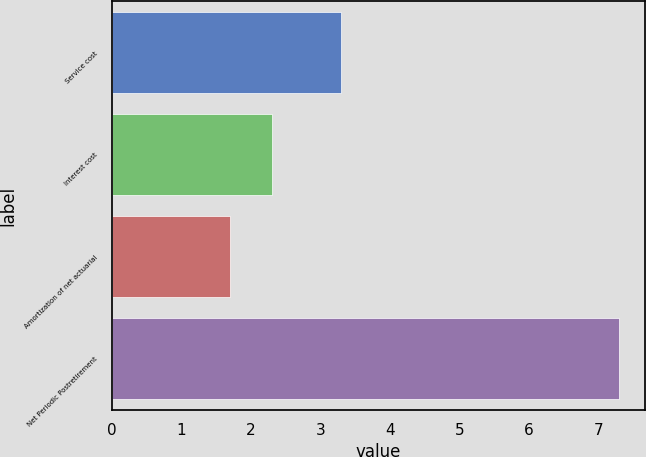<chart> <loc_0><loc_0><loc_500><loc_500><bar_chart><fcel>Service cost<fcel>Interest cost<fcel>Amortization of net actuarial<fcel>Net Periodic Postretirement<nl><fcel>3.3<fcel>2.3<fcel>1.7<fcel>7.3<nl></chart> 